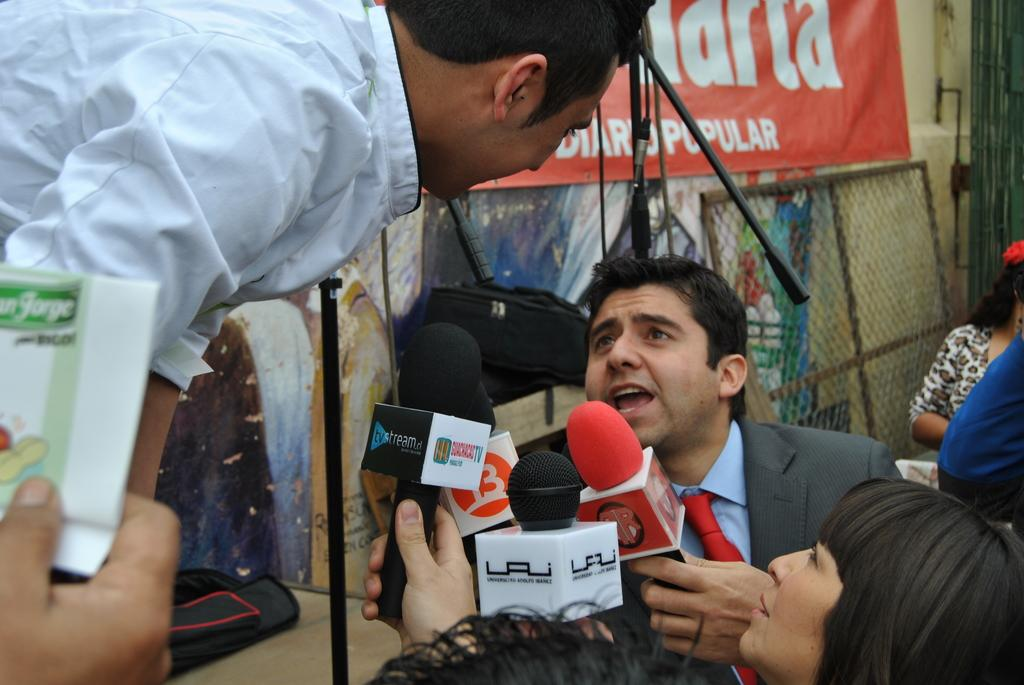What is happening in the image involving the people? The people are standing and talking to each other. What objects are in front of the people? There are microphones in front of the people. Are there any other individuals present in the image? Yes, there is another person standing nearby. What type of food is being served at the feast in the image? There is no feast or food present in the image; it features people standing and talking to each other with microphones in front of them. What color is the curtain behind the people in the image? There is no curtain visible in the image. 